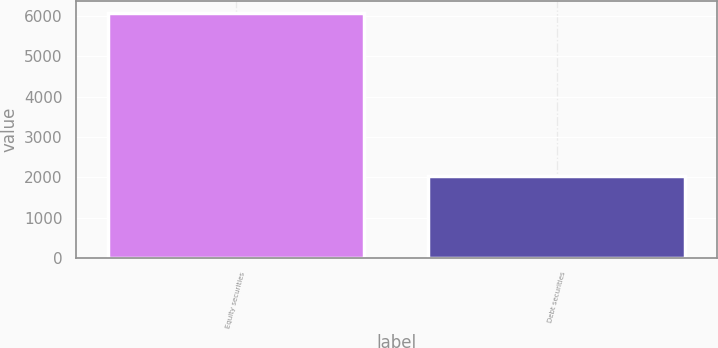Convert chart. <chart><loc_0><loc_0><loc_500><loc_500><bar_chart><fcel>Equity securities<fcel>Debt securities<nl><fcel>6080<fcel>2030<nl></chart> 